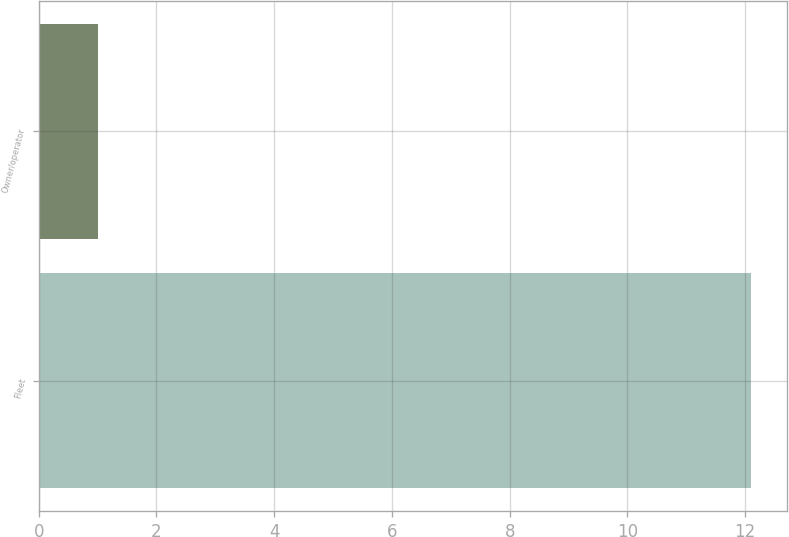<chart> <loc_0><loc_0><loc_500><loc_500><bar_chart><fcel>Fleet<fcel>Owner/operator<nl><fcel>12.1<fcel>1<nl></chart> 